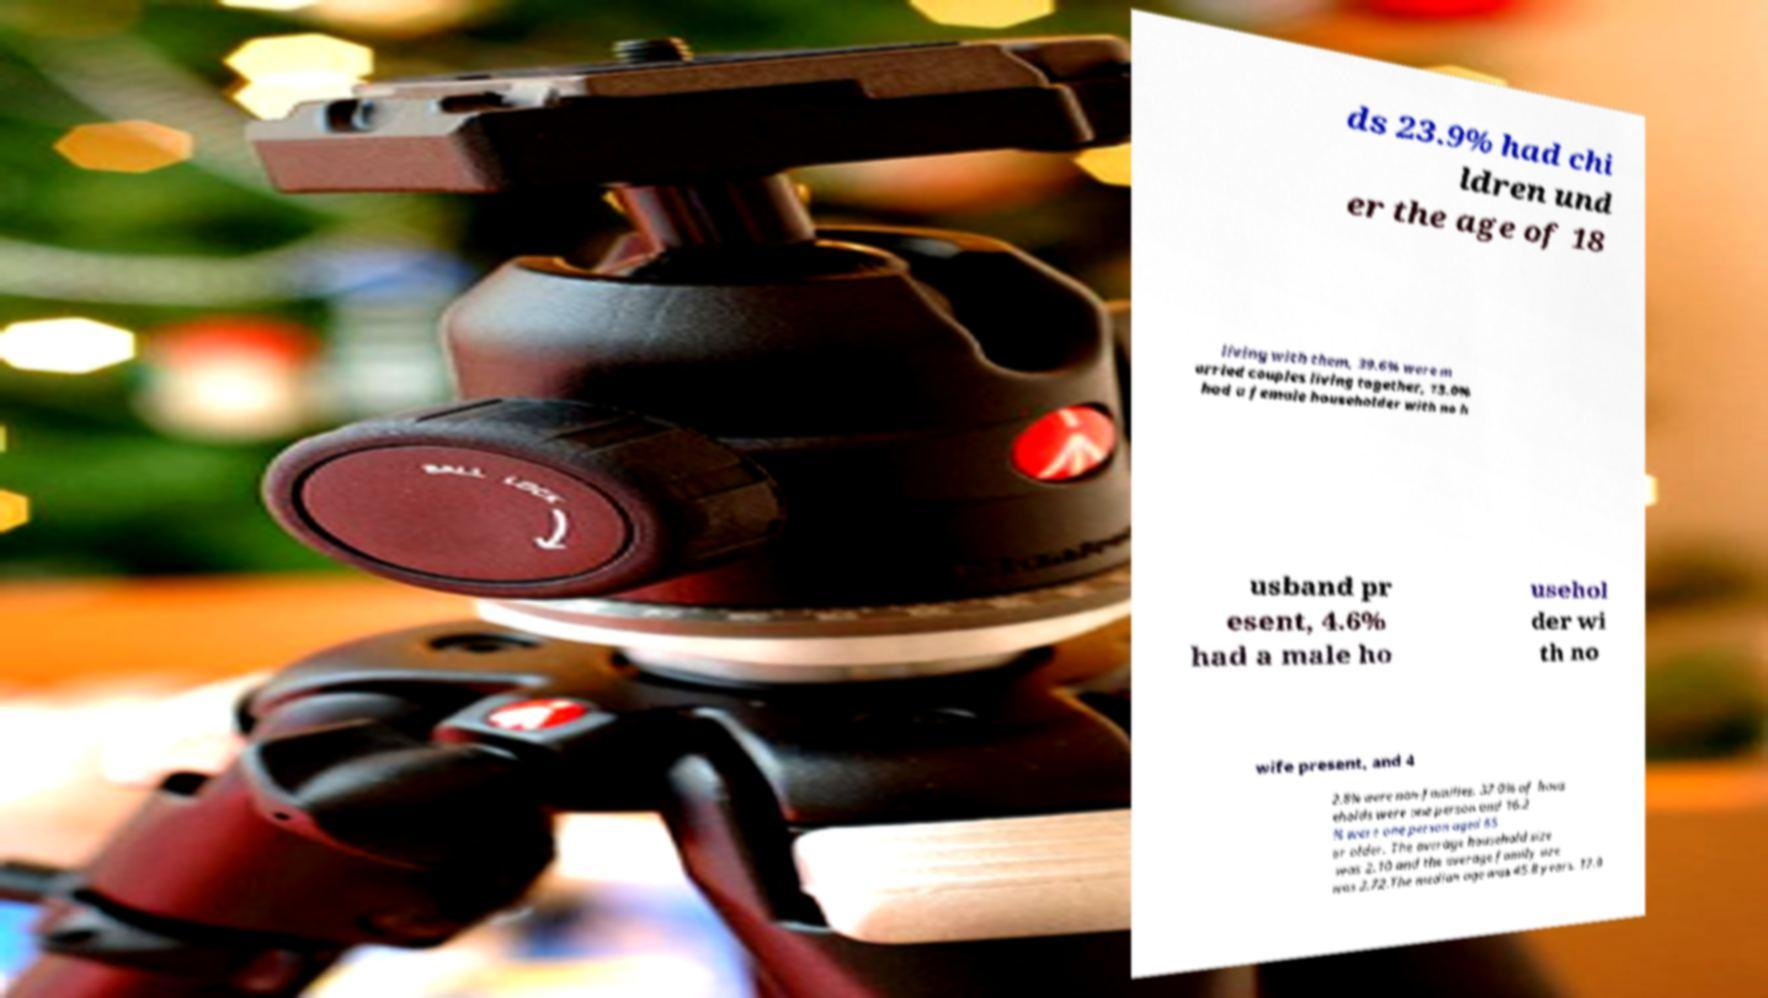There's text embedded in this image that I need extracted. Can you transcribe it verbatim? ds 23.9% had chi ldren und er the age of 18 living with them, 39.6% were m arried couples living together, 13.0% had a female householder with no h usband pr esent, 4.6% had a male ho usehol der wi th no wife present, and 4 2.8% were non-families. 37.0% of hous eholds were one person and 16.2 % were one person aged 65 or older. The average household size was 2.10 and the average family size was 2.72.The median age was 45.8 years. 17.9 